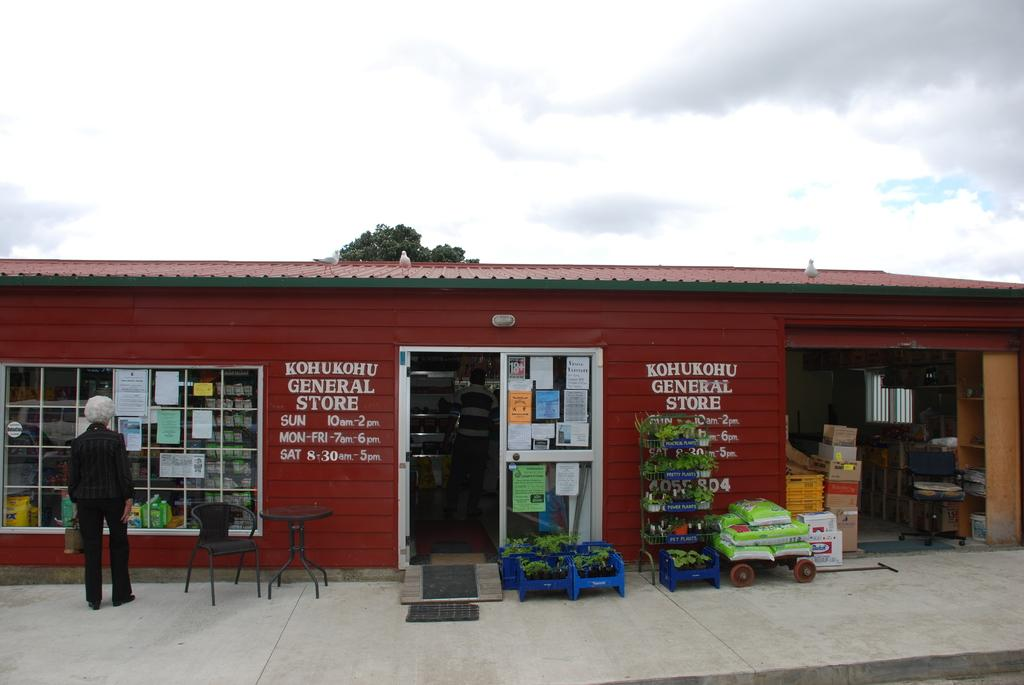<image>
Share a concise interpretation of the image provided. An image of the storefront of the Kohukohu General Store. 